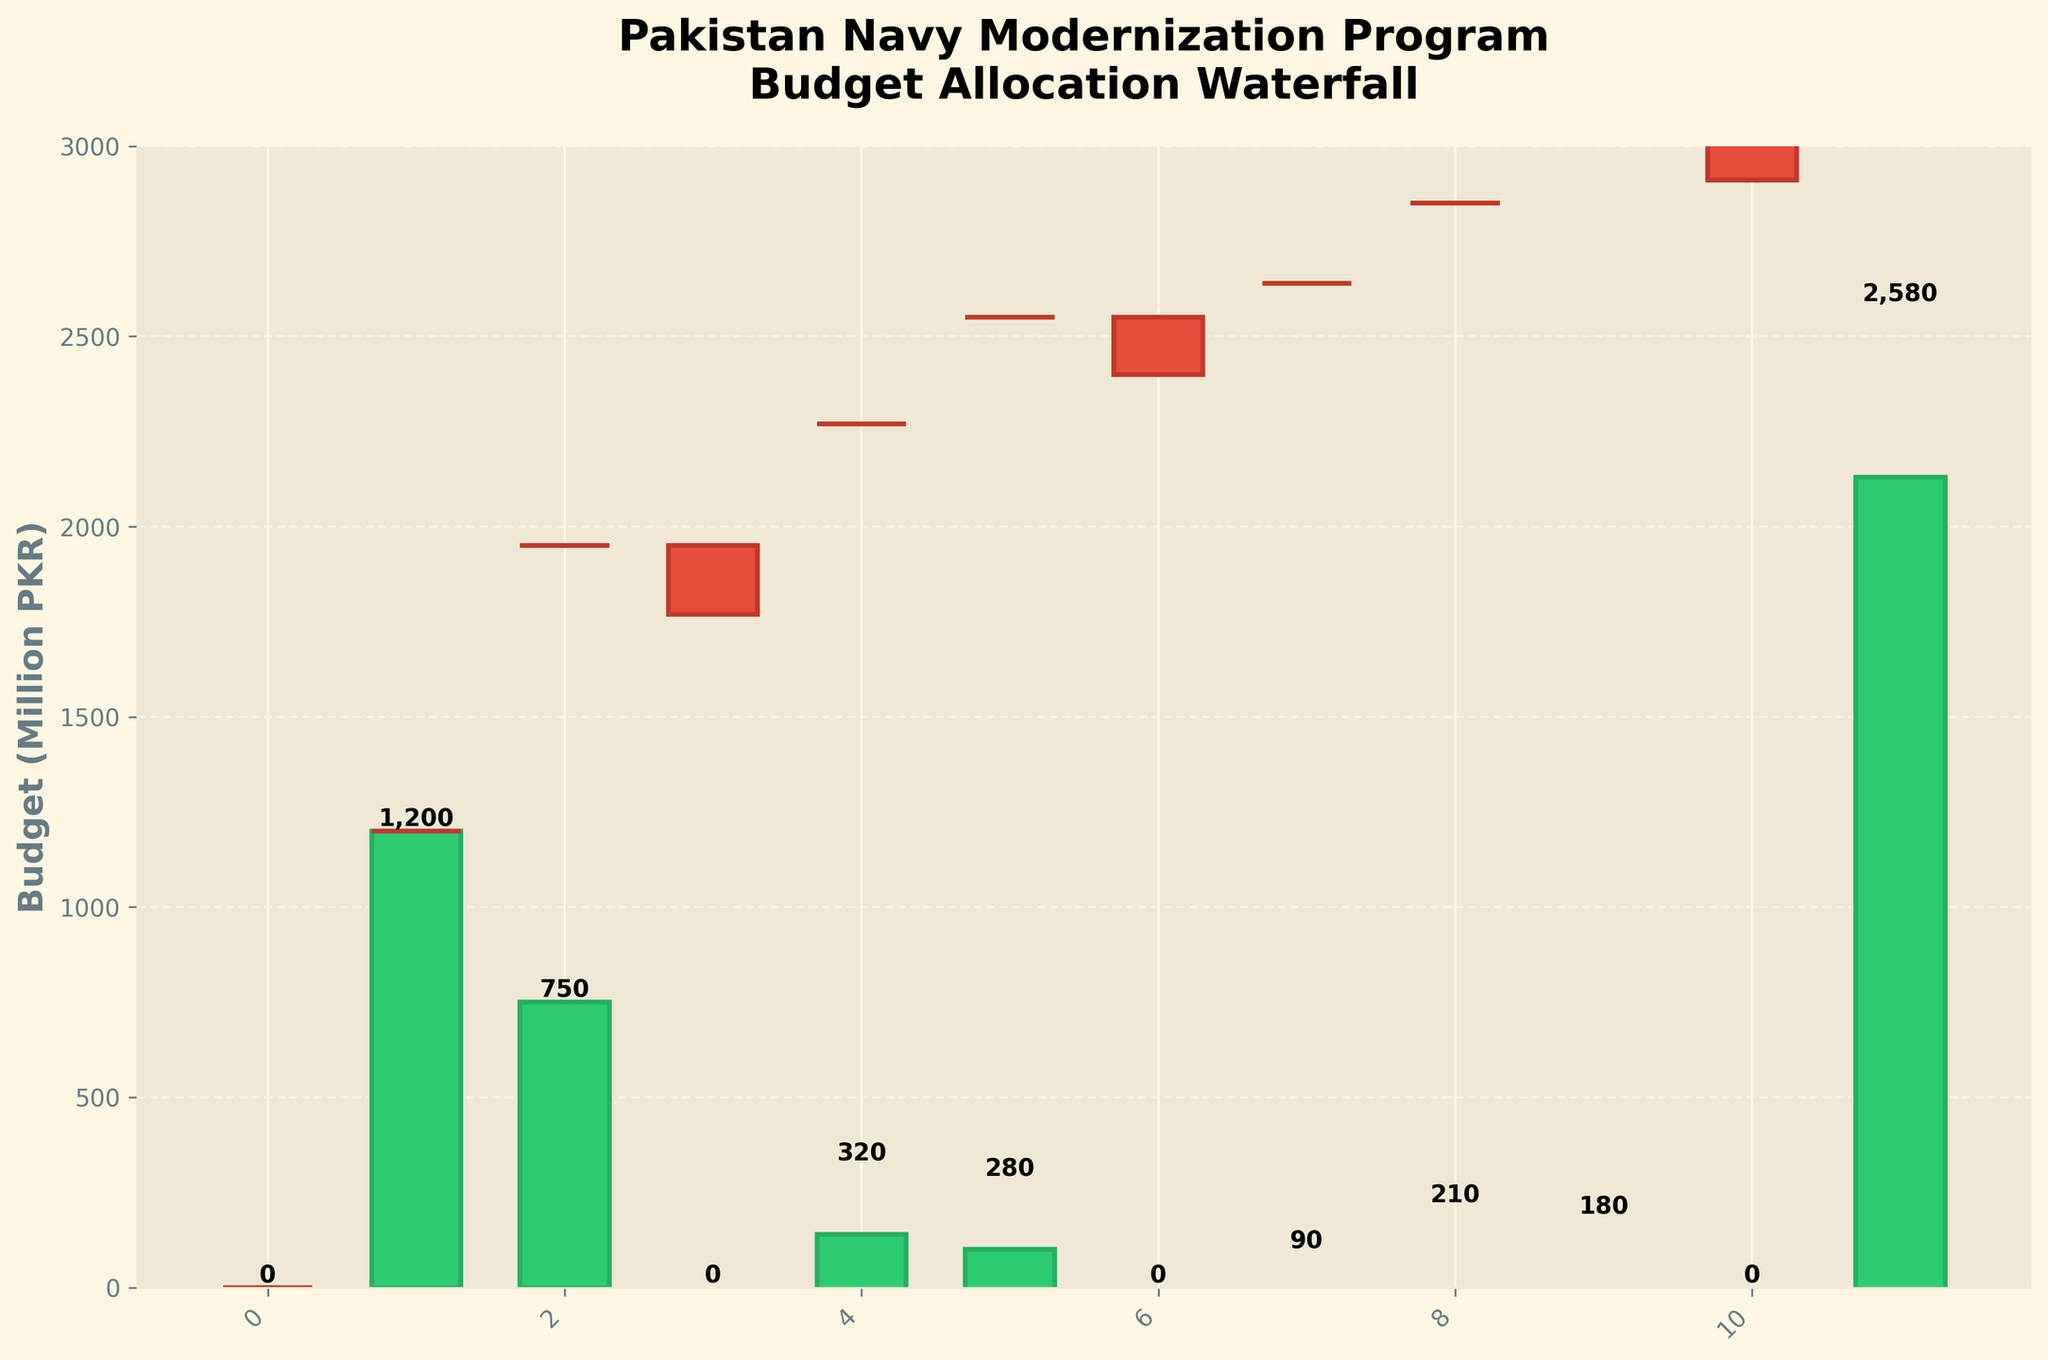Who created this chart and what is its title? The title of the chart, "Pakistan Navy Modernization Program Budget Allocation Waterfall," is prominently displayed at the top. The chart was created based on the data provided for different budget allocations and expenditures in the modernization program.
Answer: Pakistan Navy Modernization Program Budget Allocation Waterfall What are the positive expenditures shown in the chart? The positive expenditures are those with values above zero. They include Submarine Acquisition, F-22P Frigate Program, Missile Systems Upgrade, Coastal Defense Enhancement, Training Simulators, Dockyard Expansion, and Anti-Ship Missiles, as they are shown in green bars.
Answer: Submarine Acquisition, F-22P Frigate Program, Missile Systems Upgrade, Coastal Defense Enhancement, Training Simulators, Dockyard Expansion, Anti-Ship Missiles What are the negative expenditures shown in the chart? The negative expenditures are those with values below zero. They include Maritime Patrol Aircraft, Naval Base Modernization, and Naval Aviation Upgrade, depicted in red bars.
Answer: Maritime Patrol Aircraft, Naval Base Modernization, Naval Aviation Upgrade What is the total budget allocated for the modernization program? The total budget is reflected at the end of the chart, labeled as "Total Modernization Budget." The cumulative impact of all the expenditures and contributions sums up to the final value at the end of the waterfall.
Answer: 2580 Which category has the highest expenditure in the modernization program? By examining the height of the green bars in the chart, the Submarine Acquisition category has the highest expenditure, as it is the tallest bar on the positive side.
Answer: Submarine Acquisition What is the cumulative impact of all positive expenditures before any deductions? To find the cumulative impact of all positive expenditures, add the values of the positive bars: 1200 (Submarine Acquisition) + 750 (F-22P Frigate Program) + 320 (Missile Systems Upgrade) + 280 (Coastal Defense Enhancement) + 90 (Training Simulators) + 210 (Dockyard Expansion) + 180 (Anti-Ship Missiles) = 3030.
Answer: 3030 What deduction has the highest impact on the budget? Among the red bars, the Maritime Patrol Aircraft has the most significant deduction, as it is the tallest red bar in the chart.
Answer: Maritime Patrol Aircraft Which categories result in an overall decrease in the budget? The categories that result in an overall decrease are those represented by red bars: Maritime Patrol Aircraft, Naval Base Modernization, and Naval Aviation Upgrade.
Answer: Maritime Patrol Aircraft, Naval Base Modernization, Naval Aviation Upgrade How does the budget change immediately after the F-22P Frigate Program expenditure? After the F-22P Frigate Program expenditure of 750, the next deduction is the Maritime Patrol Aircraft at -180. The cumulative impact after these two values can be calculated as 0 (Starting Budget) + 1200 (Submarine Acquisition) + 750 (F-22P Frigate Program) = 1950, then subtracting 180 gives 1950 - 180 = 1770.
Answer: 1770 